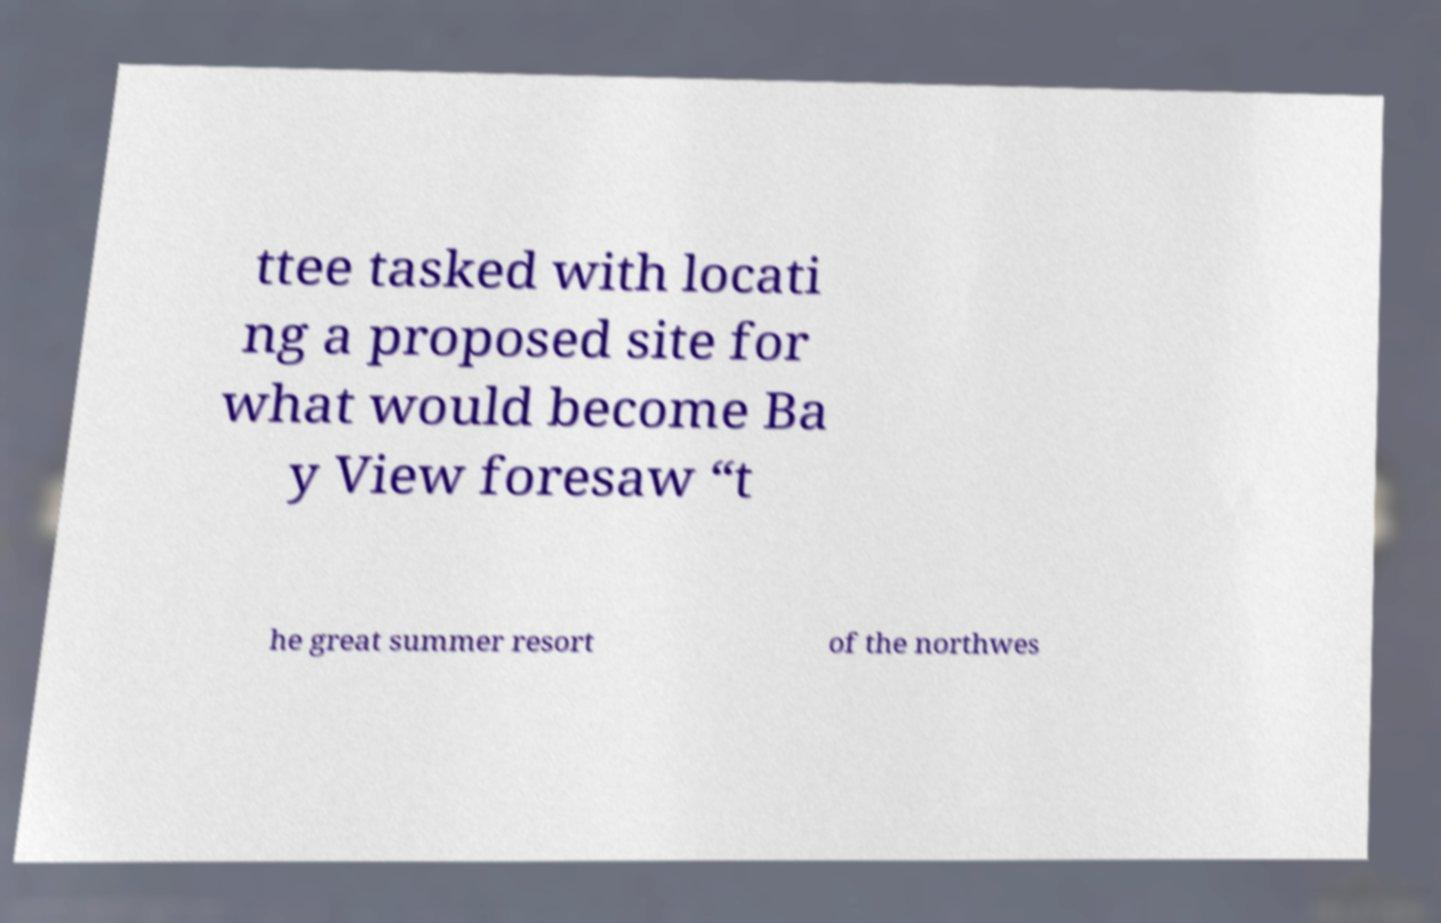What messages or text are displayed in this image? I need them in a readable, typed format. ttee tasked with locati ng a proposed site for what would become Ba y View foresaw “t he great summer resort of the northwes 